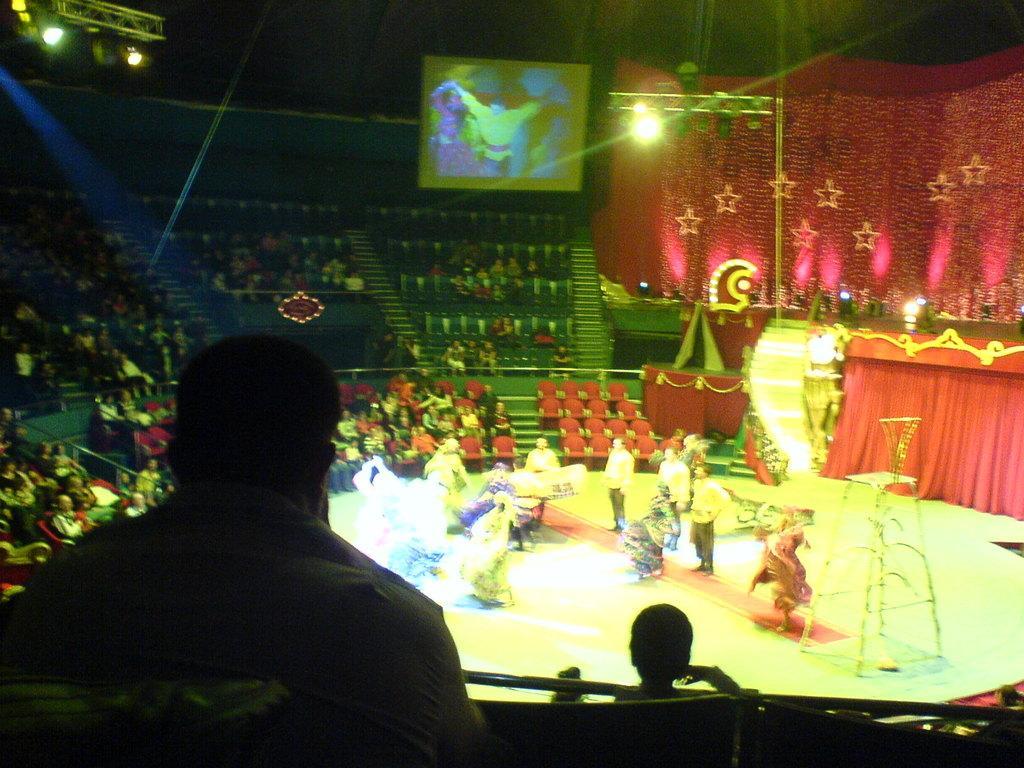In one or two sentences, can you explain what this image depicts? As we can see in the image there are group of people here and there, few people are sitting on chairs and few of them are on stage. There is a screen, lights and curtains. 